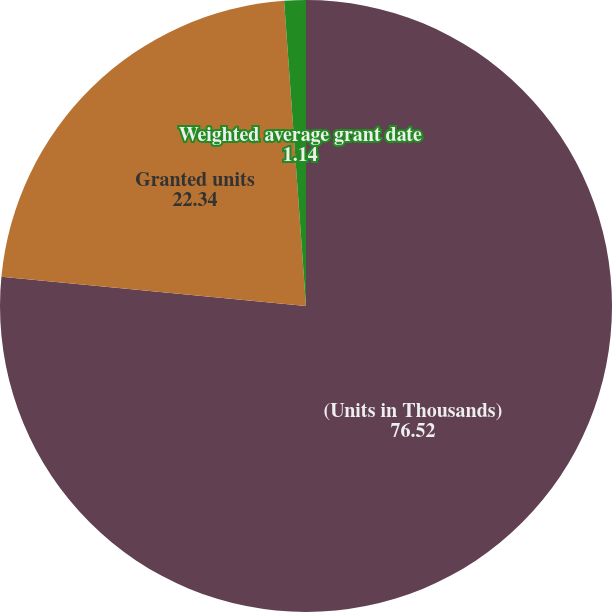<chart> <loc_0><loc_0><loc_500><loc_500><pie_chart><fcel>(Units in Thousands)<fcel>Granted units<fcel>Weighted average grant date<nl><fcel>76.52%<fcel>22.34%<fcel>1.14%<nl></chart> 